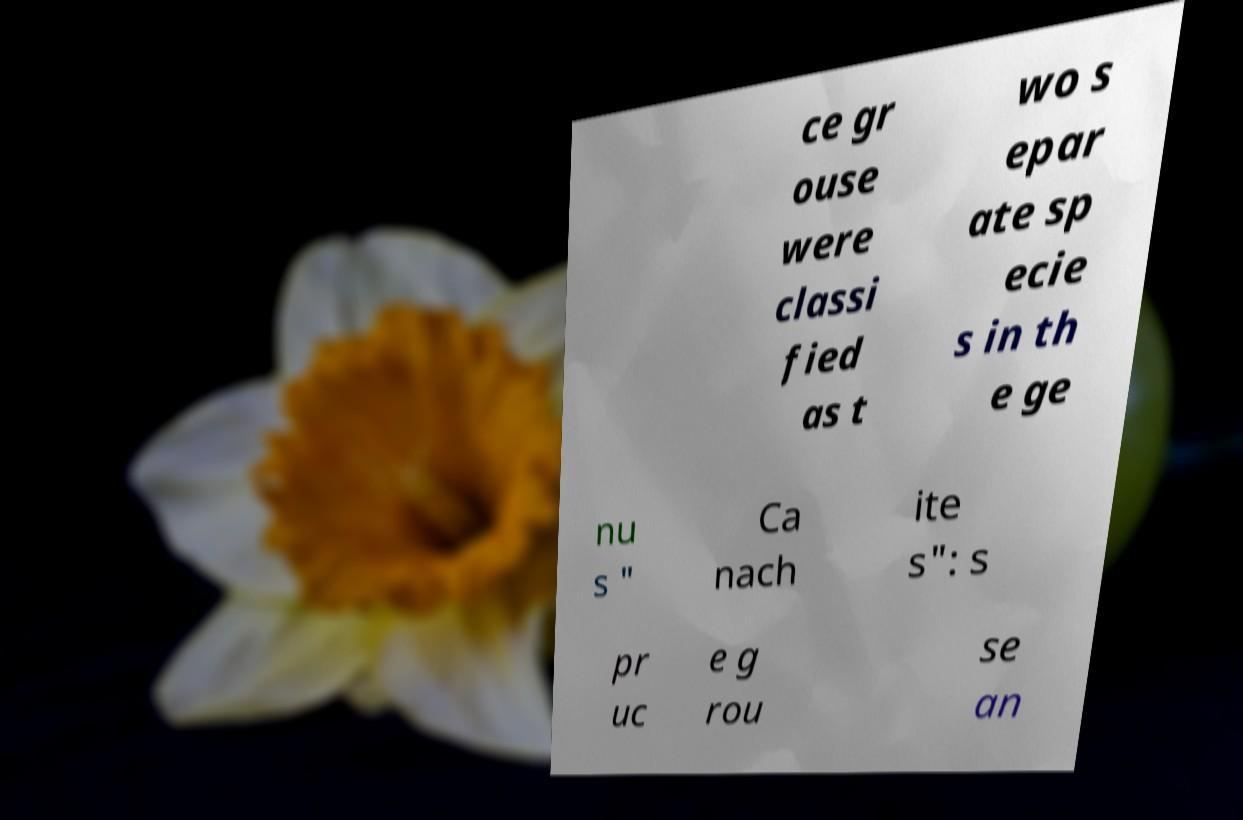There's text embedded in this image that I need extracted. Can you transcribe it verbatim? ce gr ouse were classi fied as t wo s epar ate sp ecie s in th e ge nu s " Ca nach ite s": s pr uc e g rou se an 